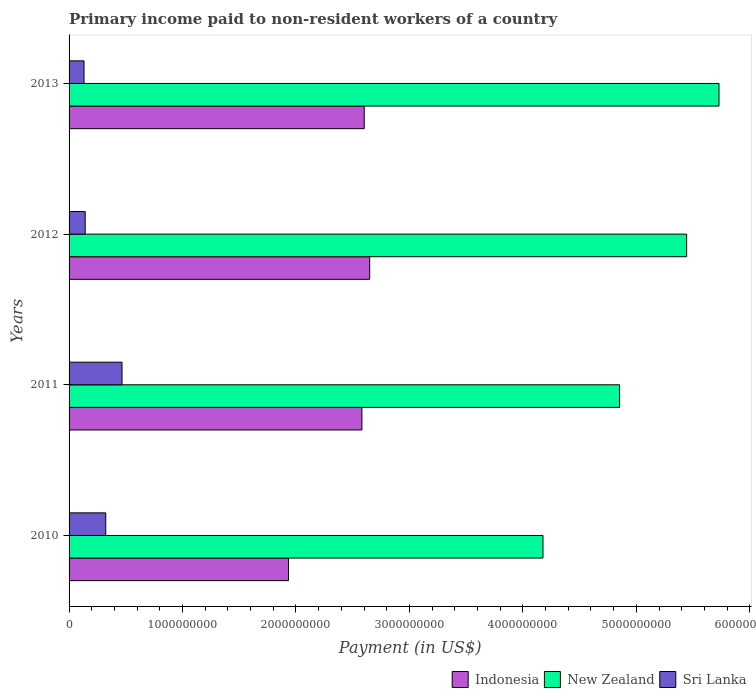How many different coloured bars are there?
Give a very brief answer. 3. How many groups of bars are there?
Ensure brevity in your answer.  4. Are the number of bars per tick equal to the number of legend labels?
Offer a very short reply. Yes. How many bars are there on the 1st tick from the bottom?
Keep it short and to the point. 3. In how many cases, is the number of bars for a given year not equal to the number of legend labels?
Your answer should be compact. 0. What is the amount paid to workers in Sri Lanka in 2013?
Provide a succinct answer. 1.32e+08. Across all years, what is the maximum amount paid to workers in Sri Lanka?
Offer a terse response. 4.67e+08. Across all years, what is the minimum amount paid to workers in Indonesia?
Your answer should be compact. 1.93e+09. In which year was the amount paid to workers in New Zealand minimum?
Offer a terse response. 2010. What is the total amount paid to workers in Sri Lanka in the graph?
Offer a terse response. 1.06e+09. What is the difference between the amount paid to workers in Sri Lanka in 2010 and that in 2012?
Keep it short and to the point. 1.81e+08. What is the difference between the amount paid to workers in New Zealand in 2010 and the amount paid to workers in Indonesia in 2012?
Your answer should be very brief. 1.53e+09. What is the average amount paid to workers in Indonesia per year?
Give a very brief answer. 2.44e+09. In the year 2010, what is the difference between the amount paid to workers in Indonesia and amount paid to workers in Sri Lanka?
Keep it short and to the point. 1.61e+09. What is the ratio of the amount paid to workers in New Zealand in 2012 to that in 2013?
Make the answer very short. 0.95. What is the difference between the highest and the second highest amount paid to workers in New Zealand?
Your answer should be very brief. 2.85e+08. What is the difference between the highest and the lowest amount paid to workers in Sri Lanka?
Your answer should be very brief. 3.35e+08. What does the 3rd bar from the top in 2013 represents?
Give a very brief answer. Indonesia. What does the 2nd bar from the bottom in 2013 represents?
Offer a very short reply. New Zealand. Is it the case that in every year, the sum of the amount paid to workers in Indonesia and amount paid to workers in New Zealand is greater than the amount paid to workers in Sri Lanka?
Keep it short and to the point. Yes. How many bars are there?
Keep it short and to the point. 12. Are all the bars in the graph horizontal?
Keep it short and to the point. Yes. How many years are there in the graph?
Give a very brief answer. 4. Does the graph contain any zero values?
Offer a terse response. No. Does the graph contain grids?
Offer a very short reply. No. Where does the legend appear in the graph?
Your answer should be compact. Bottom right. How many legend labels are there?
Keep it short and to the point. 3. What is the title of the graph?
Your response must be concise. Primary income paid to non-resident workers of a country. Does "Panama" appear as one of the legend labels in the graph?
Make the answer very short. No. What is the label or title of the X-axis?
Give a very brief answer. Payment (in US$). What is the label or title of the Y-axis?
Keep it short and to the point. Years. What is the Payment (in US$) in Indonesia in 2010?
Offer a very short reply. 1.93e+09. What is the Payment (in US$) in New Zealand in 2010?
Your answer should be very brief. 4.18e+09. What is the Payment (in US$) in Sri Lanka in 2010?
Your response must be concise. 3.23e+08. What is the Payment (in US$) in Indonesia in 2011?
Give a very brief answer. 2.58e+09. What is the Payment (in US$) in New Zealand in 2011?
Your response must be concise. 4.85e+09. What is the Payment (in US$) in Sri Lanka in 2011?
Offer a terse response. 4.67e+08. What is the Payment (in US$) of Indonesia in 2012?
Provide a succinct answer. 2.65e+09. What is the Payment (in US$) of New Zealand in 2012?
Your response must be concise. 5.44e+09. What is the Payment (in US$) of Sri Lanka in 2012?
Provide a succinct answer. 1.42e+08. What is the Payment (in US$) of Indonesia in 2013?
Give a very brief answer. 2.60e+09. What is the Payment (in US$) in New Zealand in 2013?
Make the answer very short. 5.73e+09. What is the Payment (in US$) in Sri Lanka in 2013?
Make the answer very short. 1.32e+08. Across all years, what is the maximum Payment (in US$) of Indonesia?
Your answer should be compact. 2.65e+09. Across all years, what is the maximum Payment (in US$) of New Zealand?
Your answer should be very brief. 5.73e+09. Across all years, what is the maximum Payment (in US$) in Sri Lanka?
Keep it short and to the point. 4.67e+08. Across all years, what is the minimum Payment (in US$) in Indonesia?
Your response must be concise. 1.93e+09. Across all years, what is the minimum Payment (in US$) in New Zealand?
Make the answer very short. 4.18e+09. Across all years, what is the minimum Payment (in US$) in Sri Lanka?
Your answer should be compact. 1.32e+08. What is the total Payment (in US$) of Indonesia in the graph?
Offer a terse response. 9.77e+09. What is the total Payment (in US$) in New Zealand in the graph?
Your response must be concise. 2.02e+1. What is the total Payment (in US$) in Sri Lanka in the graph?
Offer a terse response. 1.06e+09. What is the difference between the Payment (in US$) in Indonesia in 2010 and that in 2011?
Provide a short and direct response. -6.47e+08. What is the difference between the Payment (in US$) in New Zealand in 2010 and that in 2011?
Provide a succinct answer. -6.75e+08. What is the difference between the Payment (in US$) of Sri Lanka in 2010 and that in 2011?
Keep it short and to the point. -1.43e+08. What is the difference between the Payment (in US$) of Indonesia in 2010 and that in 2012?
Make the answer very short. -7.16e+08. What is the difference between the Payment (in US$) of New Zealand in 2010 and that in 2012?
Make the answer very short. -1.27e+09. What is the difference between the Payment (in US$) of Sri Lanka in 2010 and that in 2012?
Provide a succinct answer. 1.81e+08. What is the difference between the Payment (in US$) in Indonesia in 2010 and that in 2013?
Offer a terse response. -6.68e+08. What is the difference between the Payment (in US$) in New Zealand in 2010 and that in 2013?
Give a very brief answer. -1.55e+09. What is the difference between the Payment (in US$) of Sri Lanka in 2010 and that in 2013?
Make the answer very short. 1.91e+08. What is the difference between the Payment (in US$) of Indonesia in 2011 and that in 2012?
Provide a short and direct response. -6.85e+07. What is the difference between the Payment (in US$) in New Zealand in 2011 and that in 2012?
Offer a terse response. -5.91e+08. What is the difference between the Payment (in US$) of Sri Lanka in 2011 and that in 2012?
Your answer should be very brief. 3.24e+08. What is the difference between the Payment (in US$) in Indonesia in 2011 and that in 2013?
Give a very brief answer. -2.07e+07. What is the difference between the Payment (in US$) in New Zealand in 2011 and that in 2013?
Offer a terse response. -8.76e+08. What is the difference between the Payment (in US$) of Sri Lanka in 2011 and that in 2013?
Provide a succinct answer. 3.35e+08. What is the difference between the Payment (in US$) of Indonesia in 2012 and that in 2013?
Your answer should be compact. 4.79e+07. What is the difference between the Payment (in US$) in New Zealand in 2012 and that in 2013?
Your response must be concise. -2.85e+08. What is the difference between the Payment (in US$) of Sri Lanka in 2012 and that in 2013?
Offer a terse response. 1.05e+07. What is the difference between the Payment (in US$) of Indonesia in 2010 and the Payment (in US$) of New Zealand in 2011?
Make the answer very short. -2.92e+09. What is the difference between the Payment (in US$) in Indonesia in 2010 and the Payment (in US$) in Sri Lanka in 2011?
Give a very brief answer. 1.47e+09. What is the difference between the Payment (in US$) of New Zealand in 2010 and the Payment (in US$) of Sri Lanka in 2011?
Keep it short and to the point. 3.71e+09. What is the difference between the Payment (in US$) of Indonesia in 2010 and the Payment (in US$) of New Zealand in 2012?
Provide a succinct answer. -3.51e+09. What is the difference between the Payment (in US$) of Indonesia in 2010 and the Payment (in US$) of Sri Lanka in 2012?
Offer a very short reply. 1.79e+09. What is the difference between the Payment (in US$) of New Zealand in 2010 and the Payment (in US$) of Sri Lanka in 2012?
Keep it short and to the point. 4.03e+09. What is the difference between the Payment (in US$) in Indonesia in 2010 and the Payment (in US$) in New Zealand in 2013?
Ensure brevity in your answer.  -3.79e+09. What is the difference between the Payment (in US$) of Indonesia in 2010 and the Payment (in US$) of Sri Lanka in 2013?
Ensure brevity in your answer.  1.80e+09. What is the difference between the Payment (in US$) in New Zealand in 2010 and the Payment (in US$) in Sri Lanka in 2013?
Offer a terse response. 4.05e+09. What is the difference between the Payment (in US$) in Indonesia in 2011 and the Payment (in US$) in New Zealand in 2012?
Your answer should be very brief. -2.86e+09. What is the difference between the Payment (in US$) of Indonesia in 2011 and the Payment (in US$) of Sri Lanka in 2012?
Ensure brevity in your answer.  2.44e+09. What is the difference between the Payment (in US$) of New Zealand in 2011 and the Payment (in US$) of Sri Lanka in 2012?
Provide a succinct answer. 4.71e+09. What is the difference between the Payment (in US$) in Indonesia in 2011 and the Payment (in US$) in New Zealand in 2013?
Your response must be concise. -3.15e+09. What is the difference between the Payment (in US$) in Indonesia in 2011 and the Payment (in US$) in Sri Lanka in 2013?
Offer a terse response. 2.45e+09. What is the difference between the Payment (in US$) of New Zealand in 2011 and the Payment (in US$) of Sri Lanka in 2013?
Provide a short and direct response. 4.72e+09. What is the difference between the Payment (in US$) in Indonesia in 2012 and the Payment (in US$) in New Zealand in 2013?
Your answer should be very brief. -3.08e+09. What is the difference between the Payment (in US$) of Indonesia in 2012 and the Payment (in US$) of Sri Lanka in 2013?
Make the answer very short. 2.52e+09. What is the difference between the Payment (in US$) in New Zealand in 2012 and the Payment (in US$) in Sri Lanka in 2013?
Provide a succinct answer. 5.31e+09. What is the average Payment (in US$) of Indonesia per year?
Make the answer very short. 2.44e+09. What is the average Payment (in US$) of New Zealand per year?
Provide a succinct answer. 5.05e+09. What is the average Payment (in US$) of Sri Lanka per year?
Give a very brief answer. 2.66e+08. In the year 2010, what is the difference between the Payment (in US$) of Indonesia and Payment (in US$) of New Zealand?
Provide a succinct answer. -2.24e+09. In the year 2010, what is the difference between the Payment (in US$) in Indonesia and Payment (in US$) in Sri Lanka?
Your answer should be compact. 1.61e+09. In the year 2010, what is the difference between the Payment (in US$) of New Zealand and Payment (in US$) of Sri Lanka?
Give a very brief answer. 3.85e+09. In the year 2011, what is the difference between the Payment (in US$) in Indonesia and Payment (in US$) in New Zealand?
Make the answer very short. -2.27e+09. In the year 2011, what is the difference between the Payment (in US$) of Indonesia and Payment (in US$) of Sri Lanka?
Provide a succinct answer. 2.11e+09. In the year 2011, what is the difference between the Payment (in US$) in New Zealand and Payment (in US$) in Sri Lanka?
Provide a succinct answer. 4.39e+09. In the year 2012, what is the difference between the Payment (in US$) of Indonesia and Payment (in US$) of New Zealand?
Your answer should be compact. -2.79e+09. In the year 2012, what is the difference between the Payment (in US$) of Indonesia and Payment (in US$) of Sri Lanka?
Provide a short and direct response. 2.51e+09. In the year 2012, what is the difference between the Payment (in US$) in New Zealand and Payment (in US$) in Sri Lanka?
Offer a terse response. 5.30e+09. In the year 2013, what is the difference between the Payment (in US$) in Indonesia and Payment (in US$) in New Zealand?
Provide a succinct answer. -3.13e+09. In the year 2013, what is the difference between the Payment (in US$) of Indonesia and Payment (in US$) of Sri Lanka?
Make the answer very short. 2.47e+09. In the year 2013, what is the difference between the Payment (in US$) of New Zealand and Payment (in US$) of Sri Lanka?
Offer a terse response. 5.60e+09. What is the ratio of the Payment (in US$) of Indonesia in 2010 to that in 2011?
Offer a very short reply. 0.75. What is the ratio of the Payment (in US$) of New Zealand in 2010 to that in 2011?
Provide a short and direct response. 0.86. What is the ratio of the Payment (in US$) of Sri Lanka in 2010 to that in 2011?
Make the answer very short. 0.69. What is the ratio of the Payment (in US$) of Indonesia in 2010 to that in 2012?
Give a very brief answer. 0.73. What is the ratio of the Payment (in US$) of New Zealand in 2010 to that in 2012?
Ensure brevity in your answer.  0.77. What is the ratio of the Payment (in US$) of Sri Lanka in 2010 to that in 2012?
Your answer should be very brief. 2.27. What is the ratio of the Payment (in US$) in Indonesia in 2010 to that in 2013?
Provide a succinct answer. 0.74. What is the ratio of the Payment (in US$) of New Zealand in 2010 to that in 2013?
Ensure brevity in your answer.  0.73. What is the ratio of the Payment (in US$) of Sri Lanka in 2010 to that in 2013?
Give a very brief answer. 2.45. What is the ratio of the Payment (in US$) in Indonesia in 2011 to that in 2012?
Your answer should be very brief. 0.97. What is the ratio of the Payment (in US$) of New Zealand in 2011 to that in 2012?
Make the answer very short. 0.89. What is the ratio of the Payment (in US$) of Sri Lanka in 2011 to that in 2012?
Your response must be concise. 3.28. What is the ratio of the Payment (in US$) of New Zealand in 2011 to that in 2013?
Provide a succinct answer. 0.85. What is the ratio of the Payment (in US$) in Sri Lanka in 2011 to that in 2013?
Your answer should be very brief. 3.54. What is the ratio of the Payment (in US$) in Indonesia in 2012 to that in 2013?
Keep it short and to the point. 1.02. What is the ratio of the Payment (in US$) in New Zealand in 2012 to that in 2013?
Ensure brevity in your answer.  0.95. What is the ratio of the Payment (in US$) in Sri Lanka in 2012 to that in 2013?
Keep it short and to the point. 1.08. What is the difference between the highest and the second highest Payment (in US$) in Indonesia?
Offer a very short reply. 4.79e+07. What is the difference between the highest and the second highest Payment (in US$) of New Zealand?
Provide a short and direct response. 2.85e+08. What is the difference between the highest and the second highest Payment (in US$) of Sri Lanka?
Your answer should be compact. 1.43e+08. What is the difference between the highest and the lowest Payment (in US$) of Indonesia?
Provide a short and direct response. 7.16e+08. What is the difference between the highest and the lowest Payment (in US$) in New Zealand?
Make the answer very short. 1.55e+09. What is the difference between the highest and the lowest Payment (in US$) in Sri Lanka?
Provide a short and direct response. 3.35e+08. 